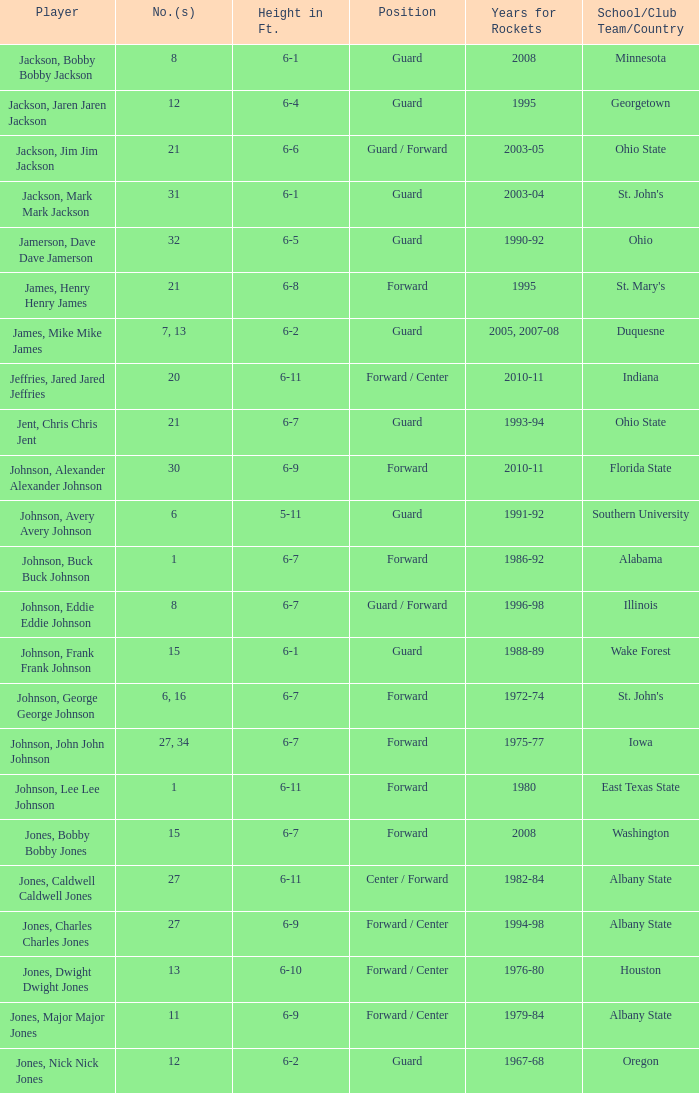What is the number of the player who went to Southern University? 6.0. 